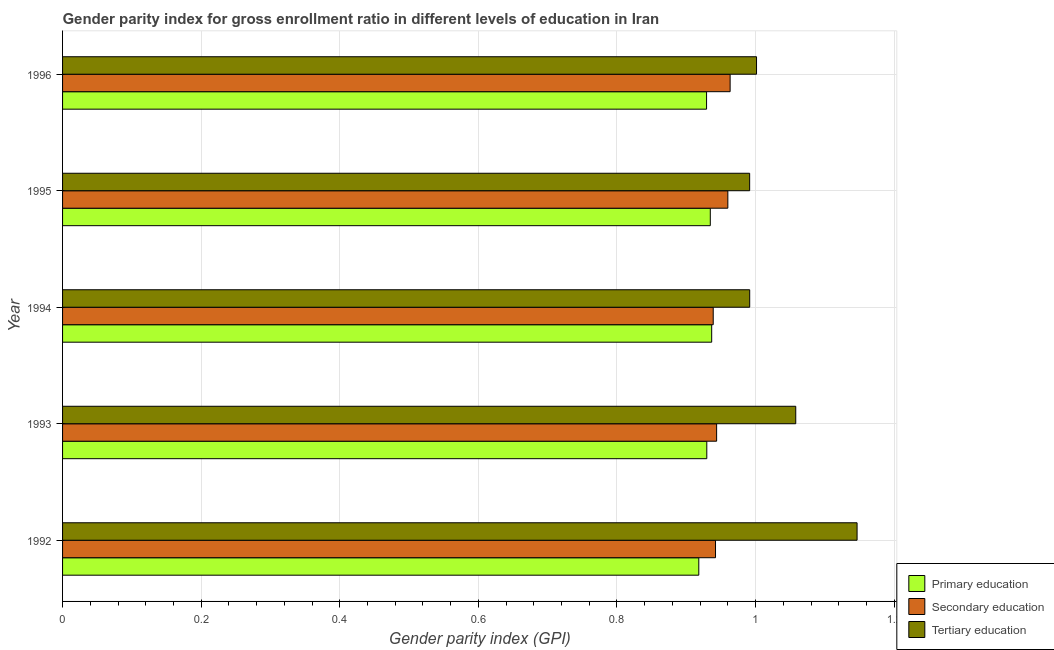How many groups of bars are there?
Keep it short and to the point. 5. Are the number of bars per tick equal to the number of legend labels?
Provide a succinct answer. Yes. Are the number of bars on each tick of the Y-axis equal?
Your response must be concise. Yes. How many bars are there on the 1st tick from the top?
Make the answer very short. 3. What is the gender parity index in primary education in 1995?
Provide a short and direct response. 0.93. Across all years, what is the maximum gender parity index in primary education?
Provide a short and direct response. 0.94. Across all years, what is the minimum gender parity index in secondary education?
Offer a terse response. 0.94. In which year was the gender parity index in secondary education maximum?
Your response must be concise. 1996. What is the total gender parity index in secondary education in the graph?
Offer a very short reply. 4.75. What is the difference between the gender parity index in tertiary education in 1992 and that in 1995?
Offer a terse response. 0.15. What is the difference between the gender parity index in primary education in 1994 and the gender parity index in secondary education in 1995?
Keep it short and to the point. -0.02. In the year 1996, what is the difference between the gender parity index in secondary education and gender parity index in primary education?
Ensure brevity in your answer.  0.03. Is the gender parity index in tertiary education in 1992 less than that in 1993?
Keep it short and to the point. No. What is the difference between the highest and the second highest gender parity index in primary education?
Your response must be concise. 0. What is the difference between the highest and the lowest gender parity index in primary education?
Your response must be concise. 0.02. Is the sum of the gender parity index in secondary education in 1992 and 1995 greater than the maximum gender parity index in tertiary education across all years?
Provide a succinct answer. Yes. What does the 2nd bar from the bottom in 1995 represents?
Your answer should be very brief. Secondary education. How many years are there in the graph?
Make the answer very short. 5. How many legend labels are there?
Make the answer very short. 3. How are the legend labels stacked?
Provide a short and direct response. Vertical. What is the title of the graph?
Provide a succinct answer. Gender parity index for gross enrollment ratio in different levels of education in Iran. Does "Oil" appear as one of the legend labels in the graph?
Your answer should be very brief. No. What is the label or title of the X-axis?
Your answer should be compact. Gender parity index (GPI). What is the label or title of the Y-axis?
Ensure brevity in your answer.  Year. What is the Gender parity index (GPI) of Primary education in 1992?
Provide a succinct answer. 0.92. What is the Gender parity index (GPI) of Secondary education in 1992?
Make the answer very short. 0.94. What is the Gender parity index (GPI) of Tertiary education in 1992?
Keep it short and to the point. 1.15. What is the Gender parity index (GPI) in Primary education in 1993?
Keep it short and to the point. 0.93. What is the Gender parity index (GPI) in Secondary education in 1993?
Make the answer very short. 0.94. What is the Gender parity index (GPI) in Tertiary education in 1993?
Your answer should be very brief. 1.06. What is the Gender parity index (GPI) in Primary education in 1994?
Provide a succinct answer. 0.94. What is the Gender parity index (GPI) of Secondary education in 1994?
Your answer should be very brief. 0.94. What is the Gender parity index (GPI) of Tertiary education in 1994?
Keep it short and to the point. 0.99. What is the Gender parity index (GPI) in Primary education in 1995?
Provide a succinct answer. 0.93. What is the Gender parity index (GPI) in Secondary education in 1995?
Your response must be concise. 0.96. What is the Gender parity index (GPI) of Tertiary education in 1995?
Make the answer very short. 0.99. What is the Gender parity index (GPI) in Primary education in 1996?
Your response must be concise. 0.93. What is the Gender parity index (GPI) in Secondary education in 1996?
Your answer should be compact. 0.96. What is the Gender parity index (GPI) of Tertiary education in 1996?
Offer a terse response. 1. Across all years, what is the maximum Gender parity index (GPI) in Primary education?
Provide a succinct answer. 0.94. Across all years, what is the maximum Gender parity index (GPI) in Secondary education?
Provide a succinct answer. 0.96. Across all years, what is the maximum Gender parity index (GPI) of Tertiary education?
Offer a very short reply. 1.15. Across all years, what is the minimum Gender parity index (GPI) of Primary education?
Ensure brevity in your answer.  0.92. Across all years, what is the minimum Gender parity index (GPI) in Secondary education?
Keep it short and to the point. 0.94. Across all years, what is the minimum Gender parity index (GPI) of Tertiary education?
Your response must be concise. 0.99. What is the total Gender parity index (GPI) in Primary education in the graph?
Ensure brevity in your answer.  4.65. What is the total Gender parity index (GPI) in Secondary education in the graph?
Keep it short and to the point. 4.75. What is the total Gender parity index (GPI) in Tertiary education in the graph?
Give a very brief answer. 5.19. What is the difference between the Gender parity index (GPI) of Primary education in 1992 and that in 1993?
Your answer should be compact. -0.01. What is the difference between the Gender parity index (GPI) of Secondary education in 1992 and that in 1993?
Make the answer very short. -0. What is the difference between the Gender parity index (GPI) of Tertiary education in 1992 and that in 1993?
Your response must be concise. 0.09. What is the difference between the Gender parity index (GPI) of Primary education in 1992 and that in 1994?
Keep it short and to the point. -0.02. What is the difference between the Gender parity index (GPI) of Secondary education in 1992 and that in 1994?
Your answer should be very brief. 0. What is the difference between the Gender parity index (GPI) in Tertiary education in 1992 and that in 1994?
Offer a very short reply. 0.15. What is the difference between the Gender parity index (GPI) of Primary education in 1992 and that in 1995?
Provide a succinct answer. -0.02. What is the difference between the Gender parity index (GPI) in Secondary education in 1992 and that in 1995?
Your response must be concise. -0.02. What is the difference between the Gender parity index (GPI) of Tertiary education in 1992 and that in 1995?
Provide a short and direct response. 0.15. What is the difference between the Gender parity index (GPI) of Primary education in 1992 and that in 1996?
Your answer should be very brief. -0.01. What is the difference between the Gender parity index (GPI) of Secondary education in 1992 and that in 1996?
Your answer should be very brief. -0.02. What is the difference between the Gender parity index (GPI) in Tertiary education in 1992 and that in 1996?
Your answer should be very brief. 0.15. What is the difference between the Gender parity index (GPI) in Primary education in 1993 and that in 1994?
Your response must be concise. -0.01. What is the difference between the Gender parity index (GPI) in Secondary education in 1993 and that in 1994?
Ensure brevity in your answer.  0. What is the difference between the Gender parity index (GPI) of Tertiary education in 1993 and that in 1994?
Provide a short and direct response. 0.07. What is the difference between the Gender parity index (GPI) of Primary education in 1993 and that in 1995?
Offer a terse response. -0.01. What is the difference between the Gender parity index (GPI) of Secondary education in 1993 and that in 1995?
Make the answer very short. -0.02. What is the difference between the Gender parity index (GPI) in Tertiary education in 1993 and that in 1995?
Your answer should be compact. 0.07. What is the difference between the Gender parity index (GPI) of Secondary education in 1993 and that in 1996?
Provide a short and direct response. -0.02. What is the difference between the Gender parity index (GPI) of Tertiary education in 1993 and that in 1996?
Your answer should be very brief. 0.06. What is the difference between the Gender parity index (GPI) in Primary education in 1994 and that in 1995?
Your answer should be very brief. 0. What is the difference between the Gender parity index (GPI) of Secondary education in 1994 and that in 1995?
Your response must be concise. -0.02. What is the difference between the Gender parity index (GPI) of Tertiary education in 1994 and that in 1995?
Your response must be concise. 0. What is the difference between the Gender parity index (GPI) in Primary education in 1994 and that in 1996?
Make the answer very short. 0.01. What is the difference between the Gender parity index (GPI) of Secondary education in 1994 and that in 1996?
Keep it short and to the point. -0.02. What is the difference between the Gender parity index (GPI) of Tertiary education in 1994 and that in 1996?
Provide a short and direct response. -0.01. What is the difference between the Gender parity index (GPI) in Primary education in 1995 and that in 1996?
Your answer should be very brief. 0.01. What is the difference between the Gender parity index (GPI) in Secondary education in 1995 and that in 1996?
Your answer should be compact. -0. What is the difference between the Gender parity index (GPI) of Tertiary education in 1995 and that in 1996?
Keep it short and to the point. -0.01. What is the difference between the Gender parity index (GPI) of Primary education in 1992 and the Gender parity index (GPI) of Secondary education in 1993?
Your answer should be very brief. -0.03. What is the difference between the Gender parity index (GPI) of Primary education in 1992 and the Gender parity index (GPI) of Tertiary education in 1993?
Ensure brevity in your answer.  -0.14. What is the difference between the Gender parity index (GPI) in Secondary education in 1992 and the Gender parity index (GPI) in Tertiary education in 1993?
Offer a very short reply. -0.12. What is the difference between the Gender parity index (GPI) in Primary education in 1992 and the Gender parity index (GPI) in Secondary education in 1994?
Provide a succinct answer. -0.02. What is the difference between the Gender parity index (GPI) of Primary education in 1992 and the Gender parity index (GPI) of Tertiary education in 1994?
Ensure brevity in your answer.  -0.07. What is the difference between the Gender parity index (GPI) in Secondary education in 1992 and the Gender parity index (GPI) in Tertiary education in 1994?
Provide a short and direct response. -0.05. What is the difference between the Gender parity index (GPI) of Primary education in 1992 and the Gender parity index (GPI) of Secondary education in 1995?
Offer a very short reply. -0.04. What is the difference between the Gender parity index (GPI) of Primary education in 1992 and the Gender parity index (GPI) of Tertiary education in 1995?
Provide a succinct answer. -0.07. What is the difference between the Gender parity index (GPI) of Secondary education in 1992 and the Gender parity index (GPI) of Tertiary education in 1995?
Offer a very short reply. -0.05. What is the difference between the Gender parity index (GPI) of Primary education in 1992 and the Gender parity index (GPI) of Secondary education in 1996?
Give a very brief answer. -0.05. What is the difference between the Gender parity index (GPI) in Primary education in 1992 and the Gender parity index (GPI) in Tertiary education in 1996?
Your answer should be compact. -0.08. What is the difference between the Gender parity index (GPI) in Secondary education in 1992 and the Gender parity index (GPI) in Tertiary education in 1996?
Keep it short and to the point. -0.06. What is the difference between the Gender parity index (GPI) in Primary education in 1993 and the Gender parity index (GPI) in Secondary education in 1994?
Your answer should be very brief. -0.01. What is the difference between the Gender parity index (GPI) in Primary education in 1993 and the Gender parity index (GPI) in Tertiary education in 1994?
Provide a succinct answer. -0.06. What is the difference between the Gender parity index (GPI) in Secondary education in 1993 and the Gender parity index (GPI) in Tertiary education in 1994?
Make the answer very short. -0.05. What is the difference between the Gender parity index (GPI) in Primary education in 1993 and the Gender parity index (GPI) in Secondary education in 1995?
Ensure brevity in your answer.  -0.03. What is the difference between the Gender parity index (GPI) of Primary education in 1993 and the Gender parity index (GPI) of Tertiary education in 1995?
Give a very brief answer. -0.06. What is the difference between the Gender parity index (GPI) in Secondary education in 1993 and the Gender parity index (GPI) in Tertiary education in 1995?
Give a very brief answer. -0.05. What is the difference between the Gender parity index (GPI) in Primary education in 1993 and the Gender parity index (GPI) in Secondary education in 1996?
Give a very brief answer. -0.03. What is the difference between the Gender parity index (GPI) of Primary education in 1993 and the Gender parity index (GPI) of Tertiary education in 1996?
Your answer should be very brief. -0.07. What is the difference between the Gender parity index (GPI) of Secondary education in 1993 and the Gender parity index (GPI) of Tertiary education in 1996?
Provide a succinct answer. -0.06. What is the difference between the Gender parity index (GPI) of Primary education in 1994 and the Gender parity index (GPI) of Secondary education in 1995?
Keep it short and to the point. -0.02. What is the difference between the Gender parity index (GPI) of Primary education in 1994 and the Gender parity index (GPI) of Tertiary education in 1995?
Your response must be concise. -0.05. What is the difference between the Gender parity index (GPI) in Secondary education in 1994 and the Gender parity index (GPI) in Tertiary education in 1995?
Make the answer very short. -0.05. What is the difference between the Gender parity index (GPI) in Primary education in 1994 and the Gender parity index (GPI) in Secondary education in 1996?
Offer a terse response. -0.03. What is the difference between the Gender parity index (GPI) of Primary education in 1994 and the Gender parity index (GPI) of Tertiary education in 1996?
Your response must be concise. -0.06. What is the difference between the Gender parity index (GPI) in Secondary education in 1994 and the Gender parity index (GPI) in Tertiary education in 1996?
Your answer should be compact. -0.06. What is the difference between the Gender parity index (GPI) of Primary education in 1995 and the Gender parity index (GPI) of Secondary education in 1996?
Offer a terse response. -0.03. What is the difference between the Gender parity index (GPI) of Primary education in 1995 and the Gender parity index (GPI) of Tertiary education in 1996?
Your response must be concise. -0.07. What is the difference between the Gender parity index (GPI) of Secondary education in 1995 and the Gender parity index (GPI) of Tertiary education in 1996?
Your response must be concise. -0.04. What is the average Gender parity index (GPI) of Primary education per year?
Ensure brevity in your answer.  0.93. What is the average Gender parity index (GPI) in Secondary education per year?
Offer a very short reply. 0.95. What is the average Gender parity index (GPI) of Tertiary education per year?
Offer a very short reply. 1.04. In the year 1992, what is the difference between the Gender parity index (GPI) in Primary education and Gender parity index (GPI) in Secondary education?
Offer a very short reply. -0.02. In the year 1992, what is the difference between the Gender parity index (GPI) in Primary education and Gender parity index (GPI) in Tertiary education?
Keep it short and to the point. -0.23. In the year 1992, what is the difference between the Gender parity index (GPI) of Secondary education and Gender parity index (GPI) of Tertiary education?
Your answer should be very brief. -0.2. In the year 1993, what is the difference between the Gender parity index (GPI) in Primary education and Gender parity index (GPI) in Secondary education?
Offer a very short reply. -0.01. In the year 1993, what is the difference between the Gender parity index (GPI) in Primary education and Gender parity index (GPI) in Tertiary education?
Keep it short and to the point. -0.13. In the year 1993, what is the difference between the Gender parity index (GPI) in Secondary education and Gender parity index (GPI) in Tertiary education?
Your answer should be compact. -0.11. In the year 1994, what is the difference between the Gender parity index (GPI) of Primary education and Gender parity index (GPI) of Secondary education?
Give a very brief answer. -0. In the year 1994, what is the difference between the Gender parity index (GPI) in Primary education and Gender parity index (GPI) in Tertiary education?
Ensure brevity in your answer.  -0.05. In the year 1994, what is the difference between the Gender parity index (GPI) in Secondary education and Gender parity index (GPI) in Tertiary education?
Your response must be concise. -0.05. In the year 1995, what is the difference between the Gender parity index (GPI) of Primary education and Gender parity index (GPI) of Secondary education?
Your answer should be compact. -0.03. In the year 1995, what is the difference between the Gender parity index (GPI) in Primary education and Gender parity index (GPI) in Tertiary education?
Provide a short and direct response. -0.06. In the year 1995, what is the difference between the Gender parity index (GPI) in Secondary education and Gender parity index (GPI) in Tertiary education?
Ensure brevity in your answer.  -0.03. In the year 1996, what is the difference between the Gender parity index (GPI) of Primary education and Gender parity index (GPI) of Secondary education?
Your answer should be very brief. -0.03. In the year 1996, what is the difference between the Gender parity index (GPI) of Primary education and Gender parity index (GPI) of Tertiary education?
Your answer should be compact. -0.07. In the year 1996, what is the difference between the Gender parity index (GPI) in Secondary education and Gender parity index (GPI) in Tertiary education?
Ensure brevity in your answer.  -0.04. What is the ratio of the Gender parity index (GPI) in Primary education in 1992 to that in 1993?
Make the answer very short. 0.99. What is the ratio of the Gender parity index (GPI) of Tertiary education in 1992 to that in 1993?
Offer a very short reply. 1.08. What is the ratio of the Gender parity index (GPI) of Primary education in 1992 to that in 1994?
Provide a short and direct response. 0.98. What is the ratio of the Gender parity index (GPI) in Secondary education in 1992 to that in 1994?
Provide a short and direct response. 1. What is the ratio of the Gender parity index (GPI) in Tertiary education in 1992 to that in 1994?
Your answer should be very brief. 1.16. What is the ratio of the Gender parity index (GPI) of Primary education in 1992 to that in 1995?
Keep it short and to the point. 0.98. What is the ratio of the Gender parity index (GPI) of Secondary education in 1992 to that in 1995?
Provide a short and direct response. 0.98. What is the ratio of the Gender parity index (GPI) in Tertiary education in 1992 to that in 1995?
Your answer should be compact. 1.16. What is the ratio of the Gender parity index (GPI) of Primary education in 1992 to that in 1996?
Make the answer very short. 0.99. What is the ratio of the Gender parity index (GPI) in Secondary education in 1992 to that in 1996?
Provide a short and direct response. 0.98. What is the ratio of the Gender parity index (GPI) of Tertiary education in 1992 to that in 1996?
Offer a very short reply. 1.14. What is the ratio of the Gender parity index (GPI) of Tertiary education in 1993 to that in 1994?
Keep it short and to the point. 1.07. What is the ratio of the Gender parity index (GPI) of Secondary education in 1993 to that in 1995?
Provide a succinct answer. 0.98. What is the ratio of the Gender parity index (GPI) in Tertiary education in 1993 to that in 1995?
Ensure brevity in your answer.  1.07. What is the ratio of the Gender parity index (GPI) of Primary education in 1993 to that in 1996?
Offer a very short reply. 1. What is the ratio of the Gender parity index (GPI) of Secondary education in 1993 to that in 1996?
Make the answer very short. 0.98. What is the ratio of the Gender parity index (GPI) in Tertiary education in 1993 to that in 1996?
Offer a very short reply. 1.06. What is the ratio of the Gender parity index (GPI) of Secondary education in 1994 to that in 1995?
Give a very brief answer. 0.98. What is the ratio of the Gender parity index (GPI) of Primary education in 1994 to that in 1996?
Give a very brief answer. 1.01. What is the ratio of the Gender parity index (GPI) of Secondary education in 1994 to that in 1996?
Offer a very short reply. 0.97. What is the ratio of the Gender parity index (GPI) of Tertiary education in 1994 to that in 1996?
Your answer should be compact. 0.99. What is the ratio of the Gender parity index (GPI) of Secondary education in 1995 to that in 1996?
Offer a terse response. 1. What is the ratio of the Gender parity index (GPI) of Tertiary education in 1995 to that in 1996?
Keep it short and to the point. 0.99. What is the difference between the highest and the second highest Gender parity index (GPI) in Primary education?
Ensure brevity in your answer.  0. What is the difference between the highest and the second highest Gender parity index (GPI) of Secondary education?
Your response must be concise. 0. What is the difference between the highest and the second highest Gender parity index (GPI) in Tertiary education?
Your answer should be very brief. 0.09. What is the difference between the highest and the lowest Gender parity index (GPI) of Primary education?
Offer a terse response. 0.02. What is the difference between the highest and the lowest Gender parity index (GPI) in Secondary education?
Provide a short and direct response. 0.02. What is the difference between the highest and the lowest Gender parity index (GPI) in Tertiary education?
Your answer should be compact. 0.15. 